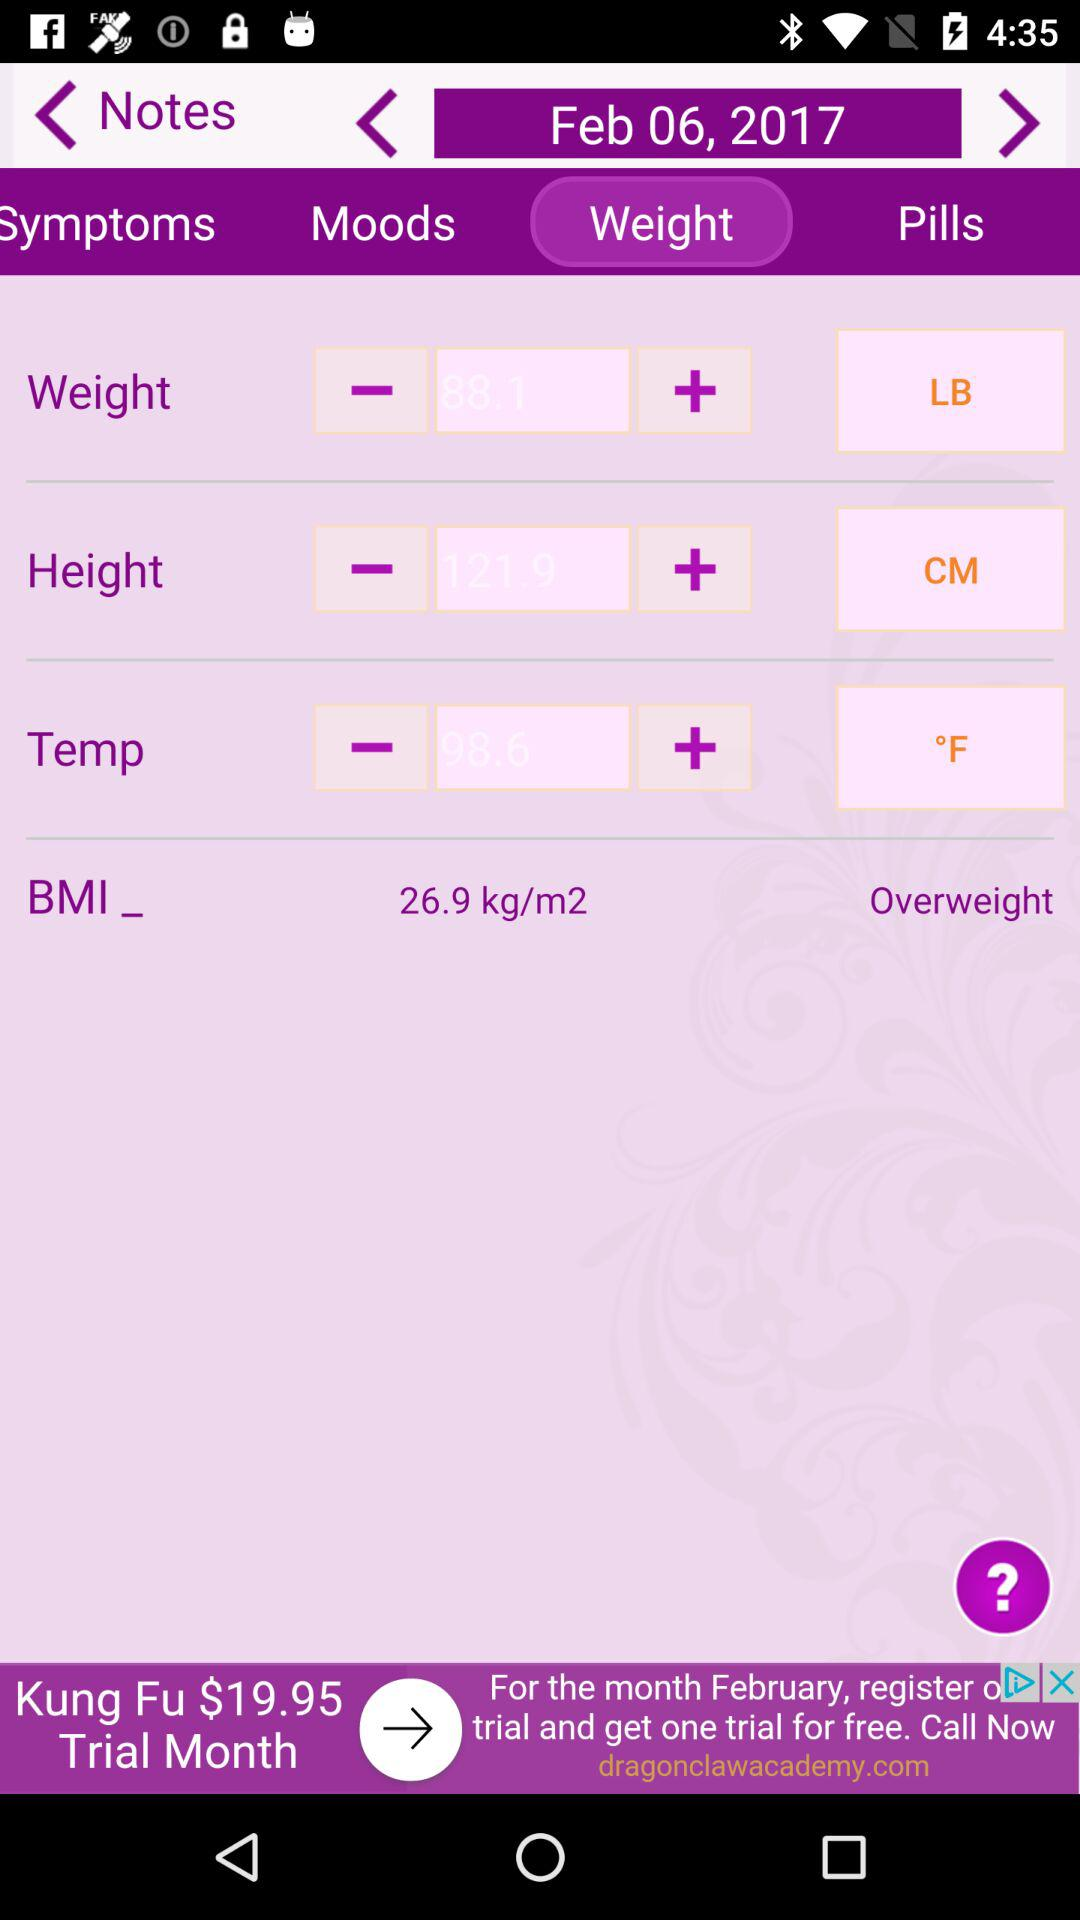What is the BMI of the user?
Answer the question using a single word or phrase. 26.9 kg/m2 